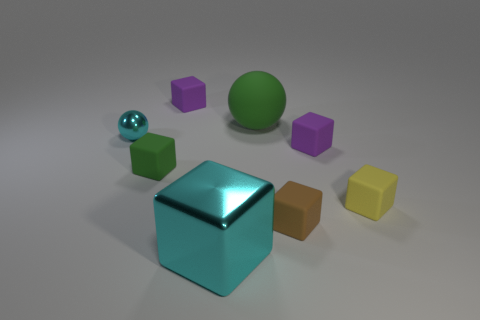Subtract all matte cubes. How many cubes are left? 1 Subtract all brown cubes. How many cubes are left? 5 Subtract all blocks. How many objects are left? 2 Subtract 1 blocks. How many blocks are left? 5 Subtract all blue cubes. How many cyan balls are left? 1 Subtract all large purple metal cylinders. Subtract all tiny metallic spheres. How many objects are left? 7 Add 3 green rubber balls. How many green rubber balls are left? 4 Add 7 small yellow shiny cylinders. How many small yellow shiny cylinders exist? 7 Add 1 brown rubber things. How many objects exist? 9 Subtract 0 blue cylinders. How many objects are left? 8 